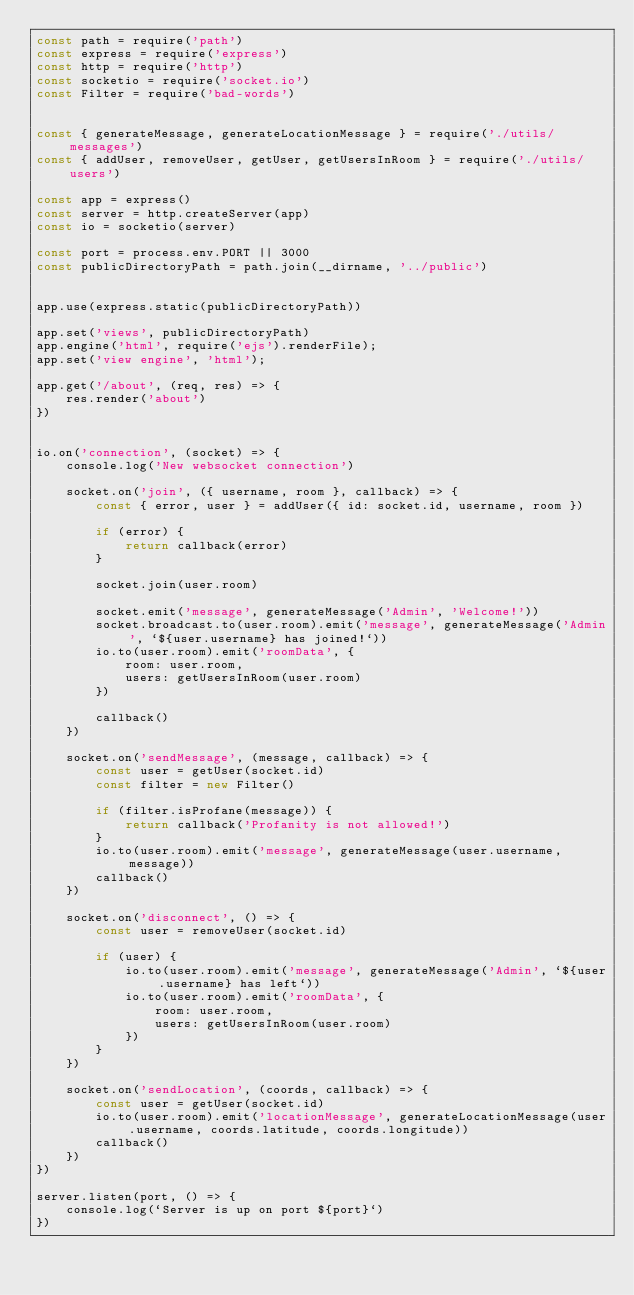<code> <loc_0><loc_0><loc_500><loc_500><_JavaScript_>const path = require('path')
const express = require('express')
const http = require('http')
const socketio = require('socket.io')
const Filter = require('bad-words')


const { generateMessage, generateLocationMessage } = require('./utils/messages')
const { addUser, removeUser, getUser, getUsersInRoom } = require('./utils/users')

const app = express()
const server = http.createServer(app)
const io = socketio(server)

const port = process.env.PORT || 3000
const publicDirectoryPath = path.join(__dirname, '../public')


app.use(express.static(publicDirectoryPath))

app.set('views', publicDirectoryPath)
app.engine('html', require('ejs').renderFile);
app.set('view engine', 'html');

app.get('/about', (req, res) => {
    res.render('about')
})


io.on('connection', (socket) => {
    console.log('New websocket connection')

    socket.on('join', ({ username, room }, callback) => {
        const { error, user } = addUser({ id: socket.id, username, room })

        if (error) {
            return callback(error)
        }

        socket.join(user.room)

        socket.emit('message', generateMessage('Admin', 'Welcome!'))
        socket.broadcast.to(user.room).emit('message', generateMessage('Admin', `${user.username} has joined!`))
        io.to(user.room).emit('roomData', {
            room: user.room,
            users: getUsersInRoom(user.room)
        })

        callback()
    })

    socket.on('sendMessage', (message, callback) => {
        const user = getUser(socket.id)
        const filter = new Filter()

        if (filter.isProfane(message)) {
            return callback('Profanity is not allowed!')
        }
        io.to(user.room).emit('message', generateMessage(user.username, message))
        callback()
    })

    socket.on('disconnect', () => {
        const user = removeUser(socket.id)

        if (user) {
            io.to(user.room).emit('message', generateMessage('Admin', `${user.username} has left`))
            io.to(user.room).emit('roomData', {
                room: user.room,
                users: getUsersInRoom(user.room)
            })
        }
    })

    socket.on('sendLocation', (coords, callback) => {
        const user = getUser(socket.id)
        io.to(user.room).emit('locationMessage', generateLocationMessage(user.username, coords.latitude, coords.longitude))
        callback()
    })
})

server.listen(port, () => {
    console.log(`Server is up on port ${port}`)
})</code> 